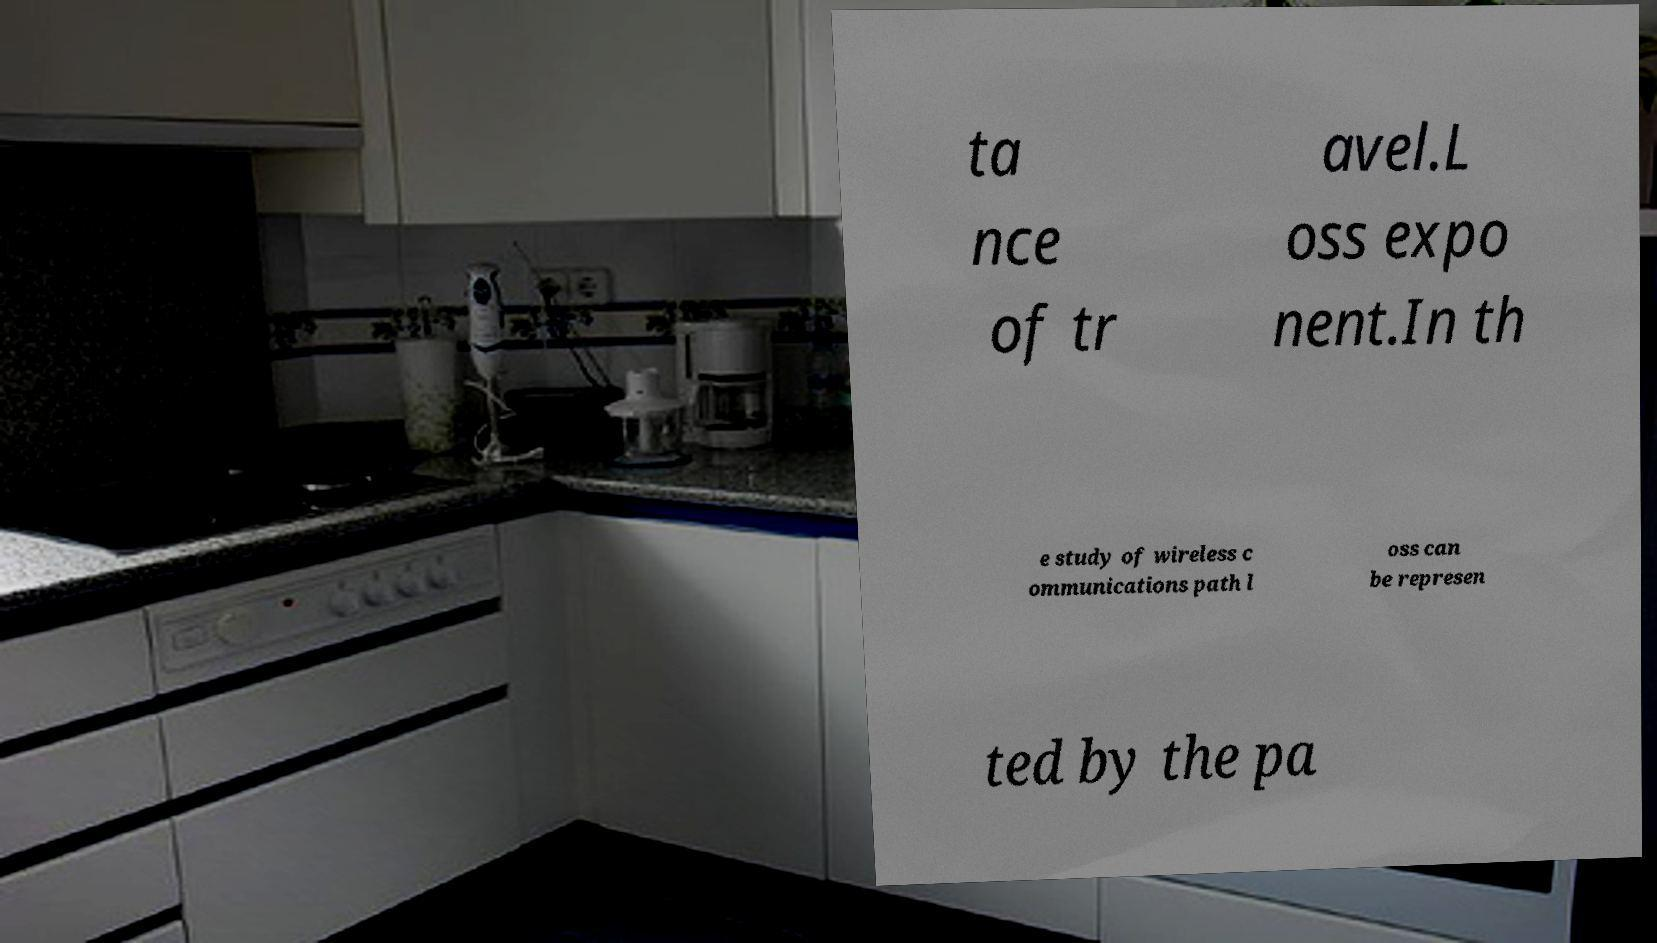Please identify and transcribe the text found in this image. ta nce of tr avel.L oss expo nent.In th e study of wireless c ommunications path l oss can be represen ted by the pa 